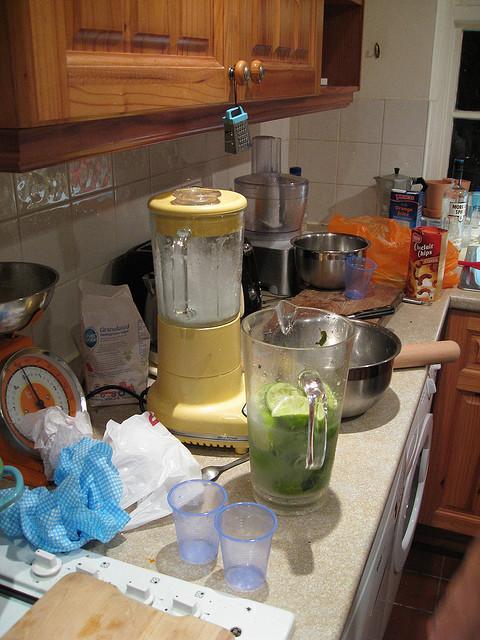Is the counter clean?
Answer briefly. No. What are the parts for?
Give a very brief answer. Cooking. Shouldn't this kitchen counter be cleaned?
Quick response, please. Yes. Are those lines in the pitcher?
Concise answer only. Yes. Is this place clean?
Short answer required. No. What substance is in the container?
Be succinct. Smoothie. Is there a screen on the counter?
Answer briefly. No. 